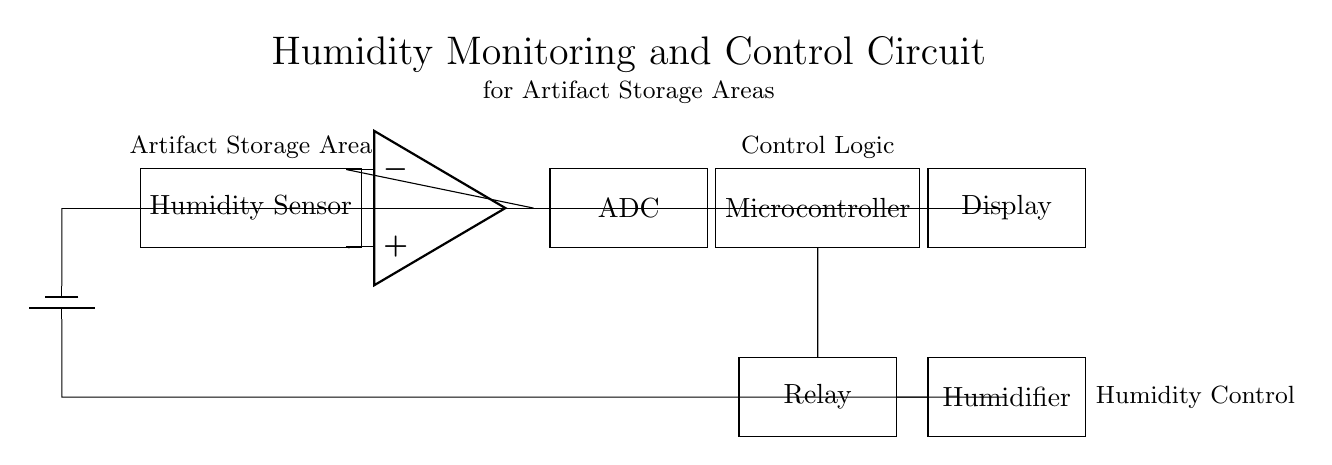What is the main function of the Humidity Sensor? The main function of the Humidity Sensor is to measure the humidity levels in the artifact storage area, indicating whether conditions are optimal for preserving artifacts.
Answer: Measure humidity What component processes the output from the Humidity Sensor? The output from the Humidity Sensor is processed by the operational amplifier, which amplifies the sensor's signal before sending it to the ADC.
Answer: Operational amplifier How is the humidity controlled in this circuit? Humidity is controlled by activating the humidifier through the relay, based on signals from the microcontroller that are determined by the ADC readings.
Answer: Through the relay What does the ADC stand for? The ADC stands for Analog-to-Digital Converter, which converts the analog signal from the operational amplifier into a digital signal for the microcontroller to process.
Answer: Analog-to-Digital Converter Which component is responsible for the display of information? The display component is responsible for showing the humidity levels and other relevant status information to the user in the artifact storage area.
Answer: Display What is the purpose of the relay in this circuit? The relay serves as a switch that controls the power supply to the humidifier based on signaling from the microcontroller, enabling humidity adjustments only when necessary.
Answer: Control humidifier What does the power supply provide to the circuit? The power supply provides the necessary voltage to all components in the circuit, ensuring they function correctly during monitoring and control operations.
Answer: Voltage 